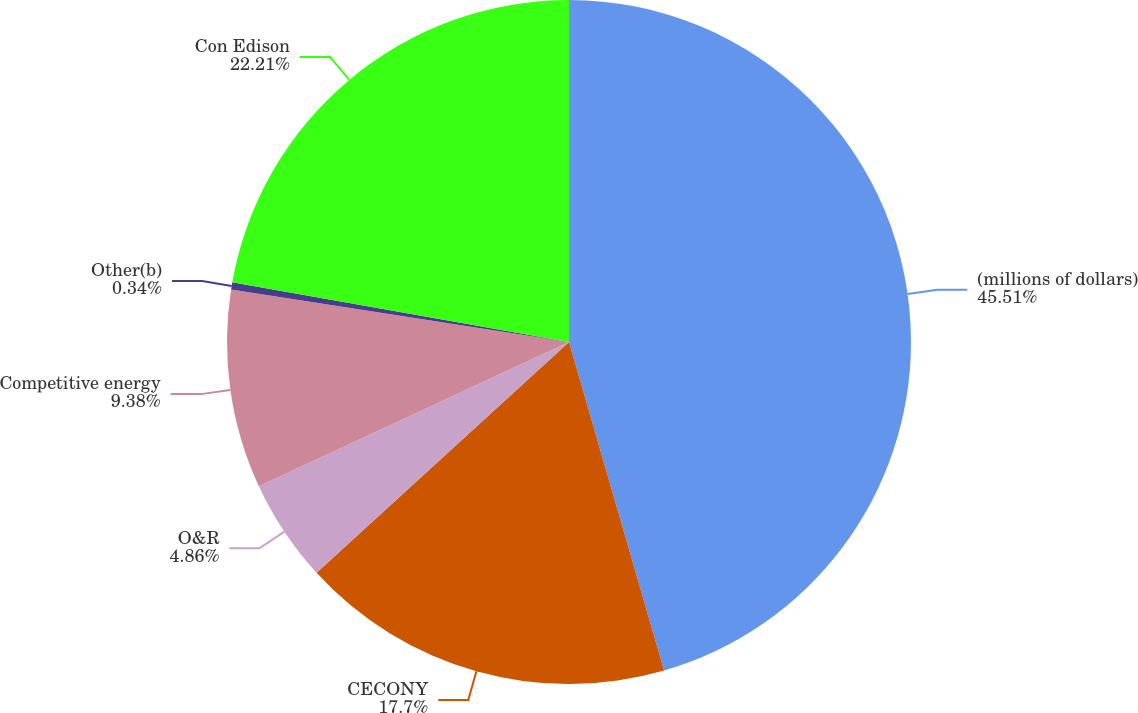Convert chart to OTSL. <chart><loc_0><loc_0><loc_500><loc_500><pie_chart><fcel>(millions of dollars)<fcel>CECONY<fcel>O&R<fcel>Competitive energy<fcel>Other(b)<fcel>Con Edison<nl><fcel>45.52%<fcel>17.7%<fcel>4.86%<fcel>9.38%<fcel>0.34%<fcel>22.21%<nl></chart> 